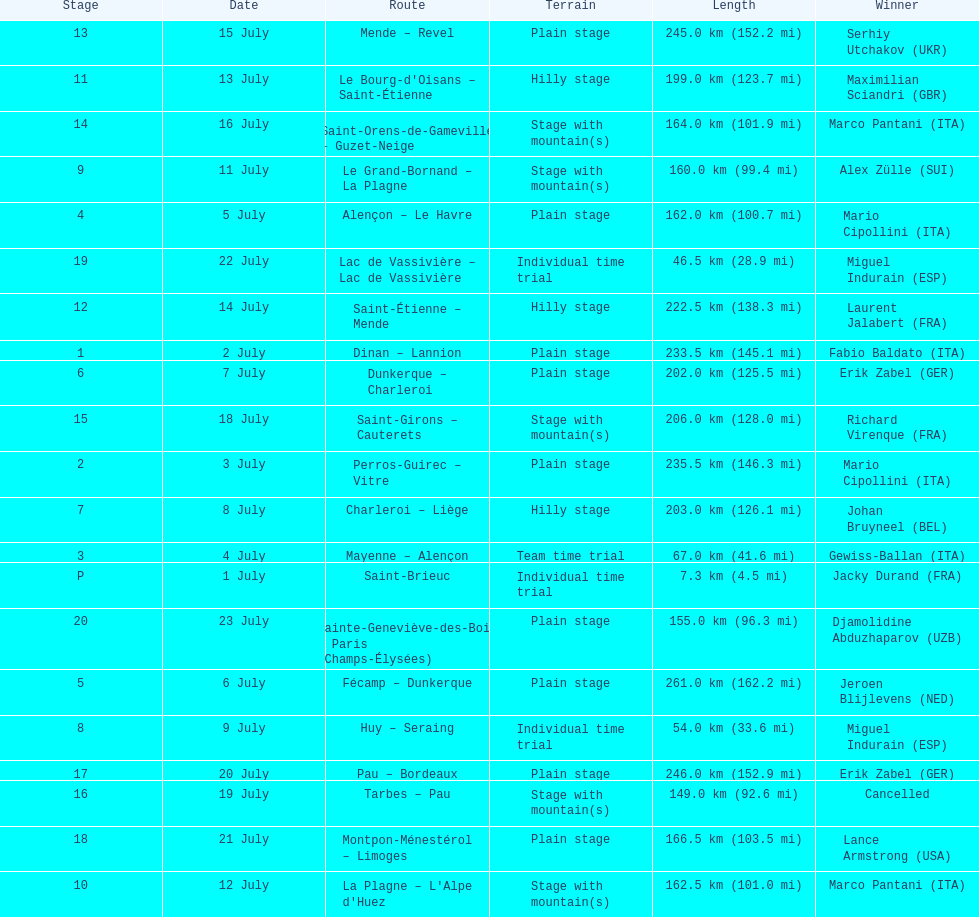Which country had more stage-winners than any other country? Italy. Parse the full table. {'header': ['Stage', 'Date', 'Route', 'Terrain', 'Length', 'Winner'], 'rows': [['13', '15 July', 'Mende – Revel', 'Plain stage', '245.0\xa0km (152.2\xa0mi)', 'Serhiy Utchakov\xa0(UKR)'], ['11', '13 July', "Le Bourg-d'Oisans – Saint-Étienne", 'Hilly stage', '199.0\xa0km (123.7\xa0mi)', 'Maximilian Sciandri\xa0(GBR)'], ['14', '16 July', 'Saint-Orens-de-Gameville – Guzet-Neige', 'Stage with mountain(s)', '164.0\xa0km (101.9\xa0mi)', 'Marco Pantani\xa0(ITA)'], ['9', '11 July', 'Le Grand-Bornand – La Plagne', 'Stage with mountain(s)', '160.0\xa0km (99.4\xa0mi)', 'Alex Zülle\xa0(SUI)'], ['4', '5 July', 'Alençon – Le Havre', 'Plain stage', '162.0\xa0km (100.7\xa0mi)', 'Mario Cipollini\xa0(ITA)'], ['19', '22 July', 'Lac de Vassivière – Lac de Vassivière', 'Individual time trial', '46.5\xa0km (28.9\xa0mi)', 'Miguel Indurain\xa0(ESP)'], ['12', '14 July', 'Saint-Étienne – Mende', 'Hilly stage', '222.5\xa0km (138.3\xa0mi)', 'Laurent Jalabert\xa0(FRA)'], ['1', '2 July', 'Dinan – Lannion', 'Plain stage', '233.5\xa0km (145.1\xa0mi)', 'Fabio Baldato\xa0(ITA)'], ['6', '7 July', 'Dunkerque – Charleroi', 'Plain stage', '202.0\xa0km (125.5\xa0mi)', 'Erik Zabel\xa0(GER)'], ['15', '18 July', 'Saint-Girons – Cauterets', 'Stage with mountain(s)', '206.0\xa0km (128.0\xa0mi)', 'Richard Virenque\xa0(FRA)'], ['2', '3 July', 'Perros-Guirec – Vitre', 'Plain stage', '235.5\xa0km (146.3\xa0mi)', 'Mario Cipollini\xa0(ITA)'], ['7', '8 July', 'Charleroi – Liège', 'Hilly stage', '203.0\xa0km (126.1\xa0mi)', 'Johan Bruyneel\xa0(BEL)'], ['3', '4 July', 'Mayenne – Alençon', 'Team time trial', '67.0\xa0km (41.6\xa0mi)', 'Gewiss-Ballan\xa0(ITA)'], ['P', '1 July', 'Saint-Brieuc', 'Individual time trial', '7.3\xa0km (4.5\xa0mi)', 'Jacky Durand\xa0(FRA)'], ['20', '23 July', 'Sainte-Geneviève-des-Bois – Paris (Champs-Élysées)', 'Plain stage', '155.0\xa0km (96.3\xa0mi)', 'Djamolidine Abduzhaparov\xa0(UZB)'], ['5', '6 July', 'Fécamp – Dunkerque', 'Plain stage', '261.0\xa0km (162.2\xa0mi)', 'Jeroen Blijlevens\xa0(NED)'], ['8', '9 July', 'Huy – Seraing', 'Individual time trial', '54.0\xa0km (33.6\xa0mi)', 'Miguel Indurain\xa0(ESP)'], ['17', '20 July', 'Pau – Bordeaux', 'Plain stage', '246.0\xa0km (152.9\xa0mi)', 'Erik Zabel\xa0(GER)'], ['16', '19 July', 'Tarbes – Pau', 'Stage with mountain(s)', '149.0\xa0km (92.6\xa0mi)', 'Cancelled'], ['18', '21 July', 'Montpon-Ménestérol – Limoges', 'Plain stage', '166.5\xa0km (103.5\xa0mi)', 'Lance Armstrong\xa0(USA)'], ['10', '12 July', "La Plagne – L'Alpe d'Huez", 'Stage with mountain(s)', '162.5\xa0km (101.0\xa0mi)', 'Marco Pantani\xa0(ITA)']]} 